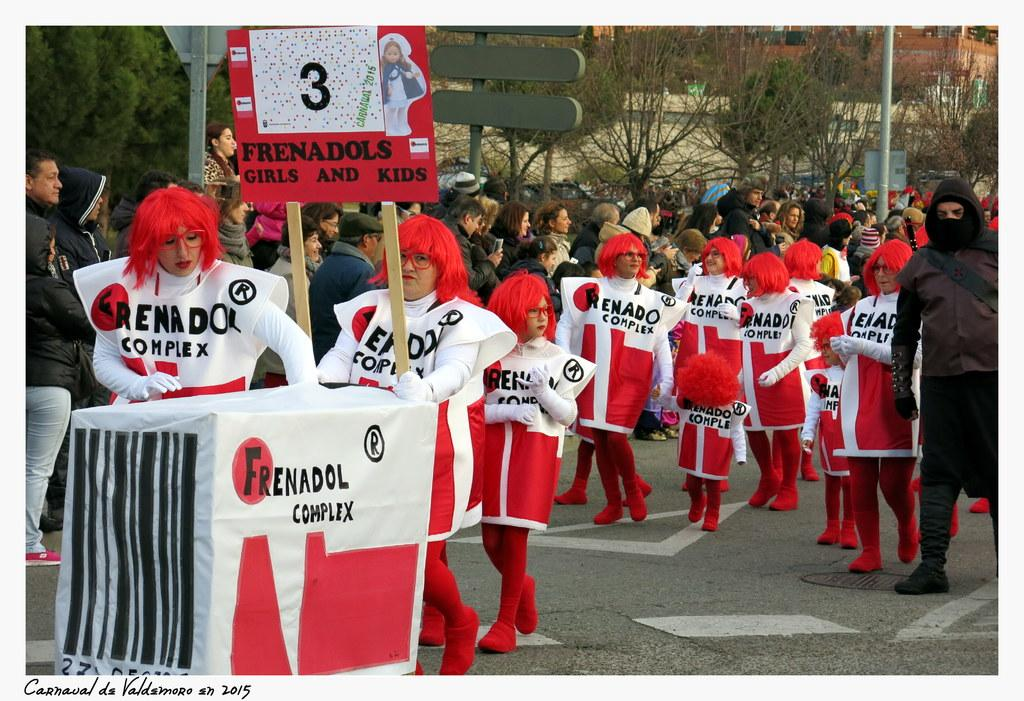<image>
Provide a brief description of the given image. A group of Frenadol Complex people marching down the street. 